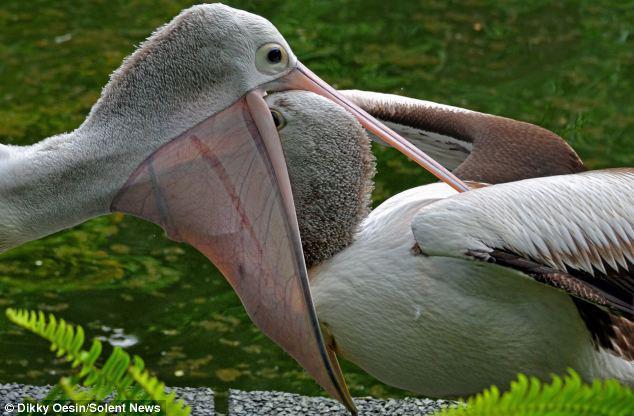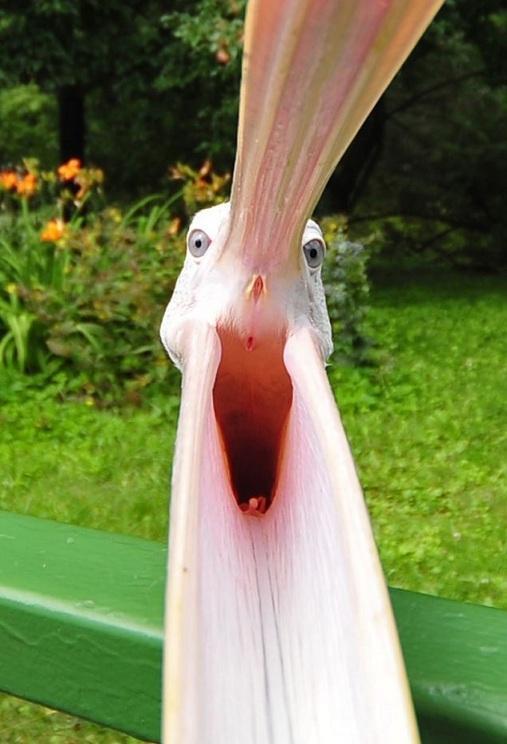The first image is the image on the left, the second image is the image on the right. Considering the images on both sides, is "One image shows a pelican with its bill closing around the head of an animal that is not a fish, and the other image shows a forward facing open-mouthed pelican." valid? Answer yes or no. Yes. The first image is the image on the left, the second image is the image on the right. Given the left and right images, does the statement "In one image, a pelican's beak is open wide so the inside can be seen, while in the other image, a pelican has an animal caught in its beak." hold true? Answer yes or no. Yes. 